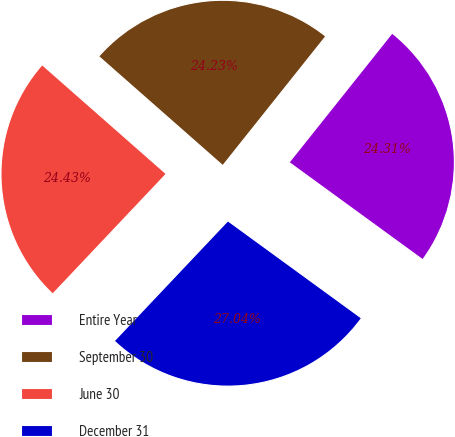<chart> <loc_0><loc_0><loc_500><loc_500><pie_chart><fcel>Entire Year<fcel>September 30<fcel>June 30<fcel>December 31<nl><fcel>24.31%<fcel>24.23%<fcel>24.43%<fcel>27.04%<nl></chart> 